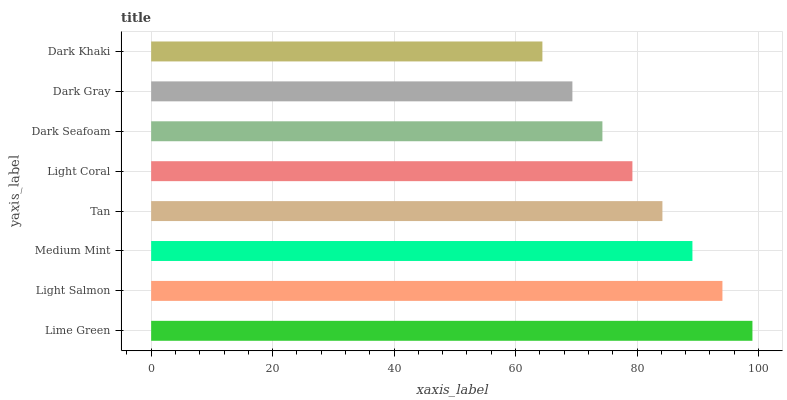Is Dark Khaki the minimum?
Answer yes or no. Yes. Is Lime Green the maximum?
Answer yes or no. Yes. Is Light Salmon the minimum?
Answer yes or no. No. Is Light Salmon the maximum?
Answer yes or no. No. Is Lime Green greater than Light Salmon?
Answer yes or no. Yes. Is Light Salmon less than Lime Green?
Answer yes or no. Yes. Is Light Salmon greater than Lime Green?
Answer yes or no. No. Is Lime Green less than Light Salmon?
Answer yes or no. No. Is Tan the high median?
Answer yes or no. Yes. Is Light Coral the low median?
Answer yes or no. Yes. Is Dark Gray the high median?
Answer yes or no. No. Is Light Salmon the low median?
Answer yes or no. No. 